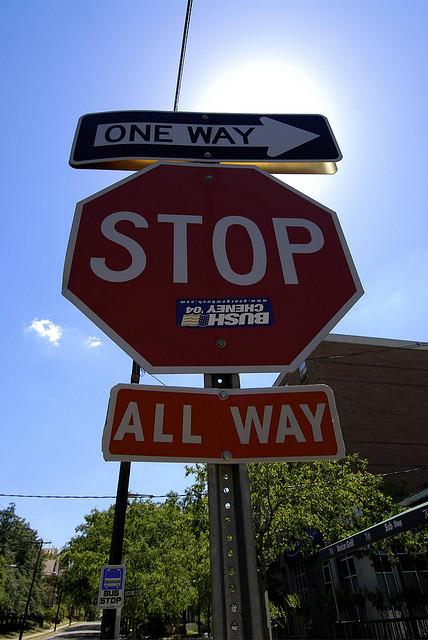What does the top sign say?
Short answer required. One way. Where is the one way sign?
Keep it brief. On top. Is the person who modified this sign liberal or conservative?
Short answer required. Conservative. Did someone interested in politics put a sticker on the stop sign?
Answer briefly. Yes. 